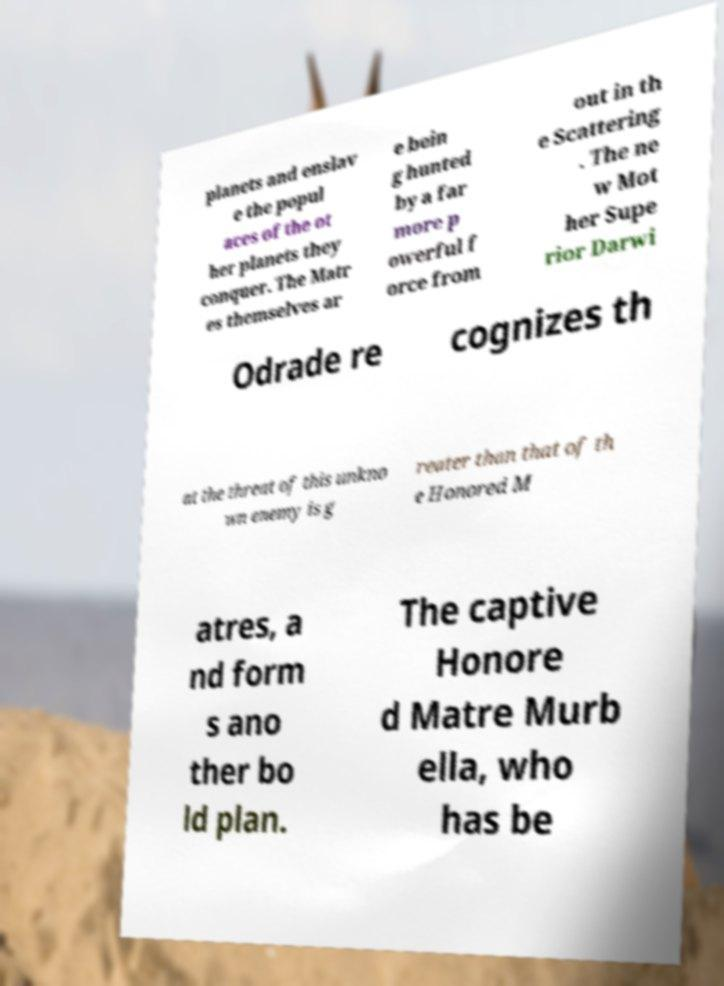Can you accurately transcribe the text from the provided image for me? planets and enslav e the popul aces of the ot her planets they conquer. The Matr es themselves ar e bein g hunted by a far more p owerful f orce from out in th e Scattering . The ne w Mot her Supe rior Darwi Odrade re cognizes th at the threat of this unkno wn enemy is g reater than that of th e Honored M atres, a nd form s ano ther bo ld plan. The captive Honore d Matre Murb ella, who has be 